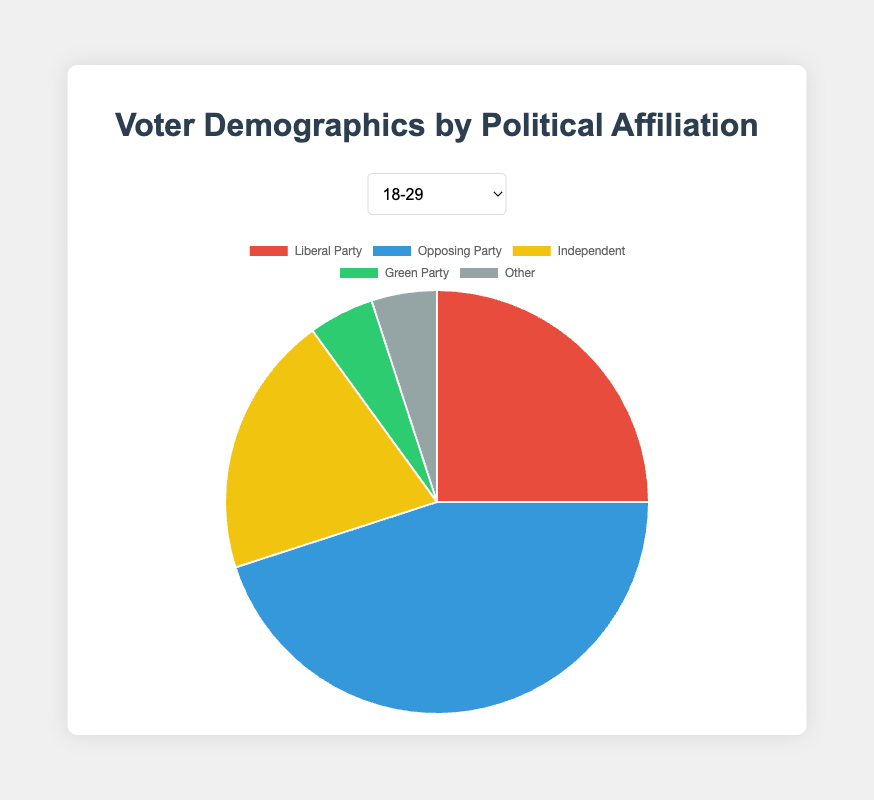Which political affiliation has the highest percentage in the 18-29 age group? By examining the pie chart for the 18-29 age group, we can see that the Opposing Party has the largest section.
Answer: Opposing Party How does the percentage of the Liberal Party in the 30-44 age group compare to the percentage in the 60 and above age group? In the 30-44 age group, the Liberal Party has 30%. In the 60 and above age group, the Liberal Party has 45%. Comparison shows that the percentage in the 60 and above group is higher.
Answer: 15% higher What's the combined percentage of Independents and Green Party in the 45-59 age group? The Independent percentage is 10% and the Green Party percentage is 10%. Adding these together gives 10% + 10% = 20%.
Answer: 20% Which age group shows the highest support for the Independent party? By comparing the pie segments labeled "Independent" across different age groups, we can observe that the 18-29 age group has the highest percentage in support of the Independent party, which is 20%.
Answer: 18-29 What is the difference in the percentage of Opposing Party supporters between the 18-29 age group and the 60 and above age group? In the 18-29 age group, the Opposing Party has 45%. In the 60 and above age group, it has 30%. The difference is 45% - 30% = 15%.
Answer: 15% How does the support for the Green Party change from the 18-29 age group to the 45-59 age group? Both the 18-29 and 45-59 age groups show a 5% and 10% support, respectively. The support increases by 5% when moving from 18-29 to 45-59 age group.
Answer: Increases by 5% What is the total percentage of voters outside of the Liberal and Opposing Party for the 60 and above age group? The remaining percentages include Independents (10%), Green Party (10%), and Other (5%). Adding these percentages together: 10% + 10% + 5% = 25%.
Answer: 25% Which age group has the smallest percentage of support for the Opposing Party? By comparing the pie segments labeled "Opposing Party" across different age groups, we find that the 60 and above age group has the smallest percentage of support at 30%.
Answer: 60 and above How does the percentage of voters supporting the "Other" category compare in all age groups? Examining the charts, the "Other" category is consistently marked at 5% in all age groups. This shows no variation across age groups.
Answer: Same across all groups (5%) What is the average percentage of Liberal Party supporters across all age groups? Summing up the percentages of the Liberal Party supporters across all age groups: 25% (18-29), 30% (30-44), 35% (45-59), 45% (60 and above). The total is 25 + 30 + 35 + 45 = 135%. Dividing by 4 age groups gives 135% / 4 = 33.75%.
Answer: 33.75% 